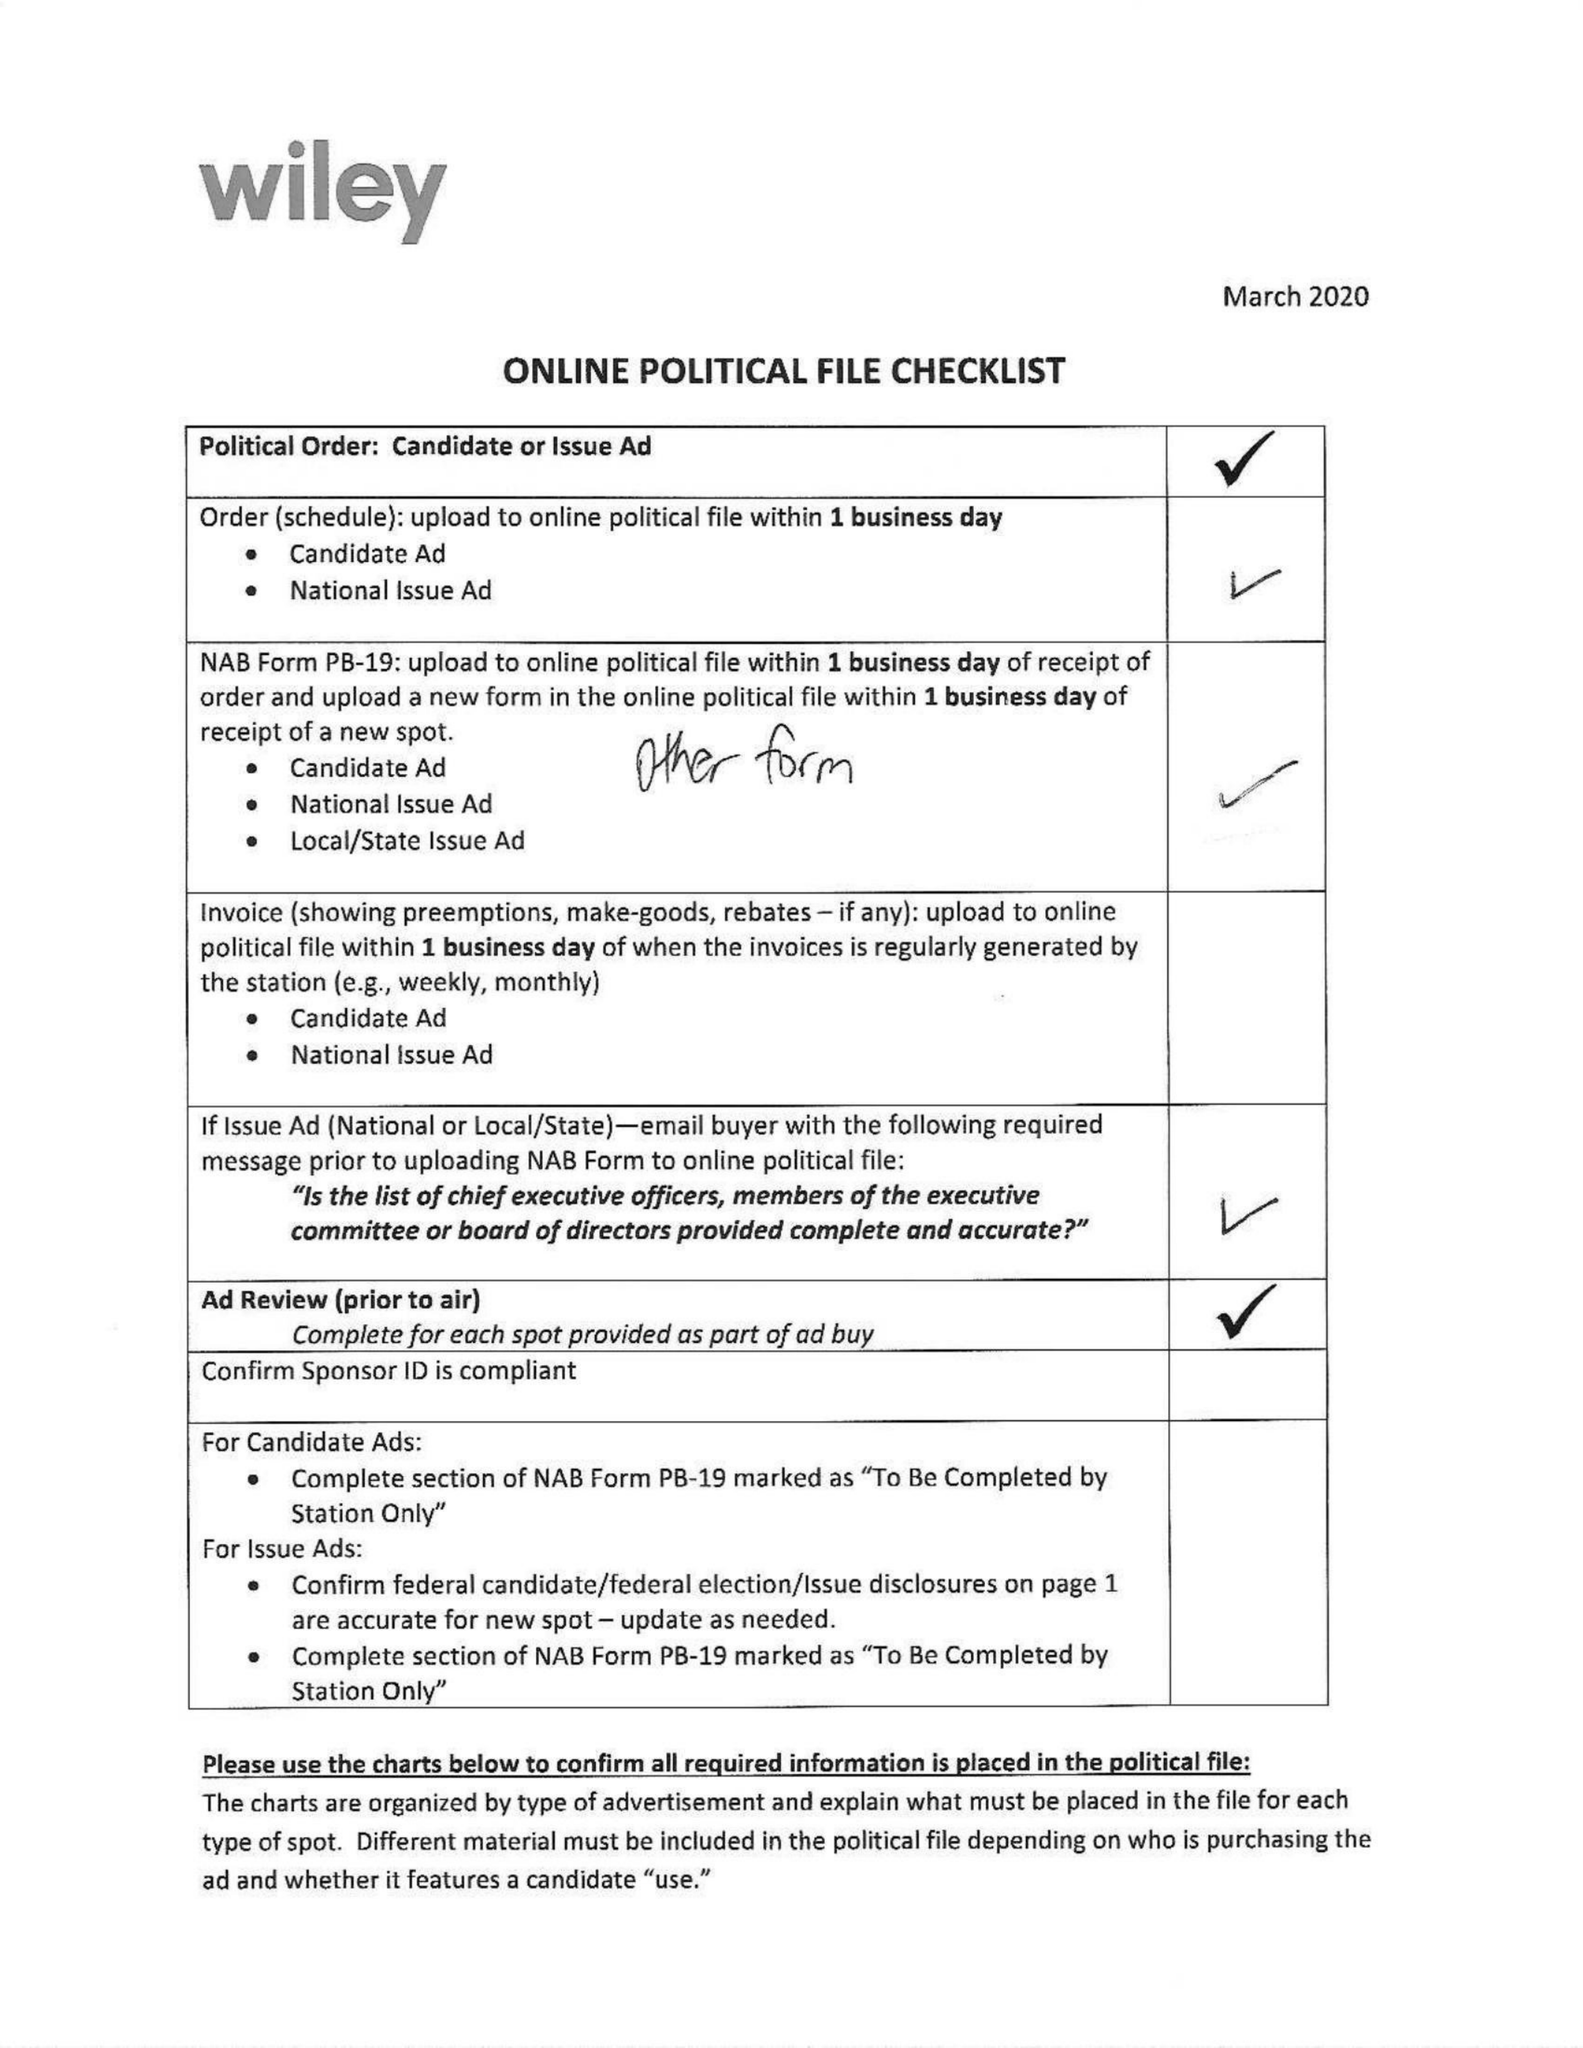What is the value for the contract_num?
Answer the question using a single word or phrase. 1598619 